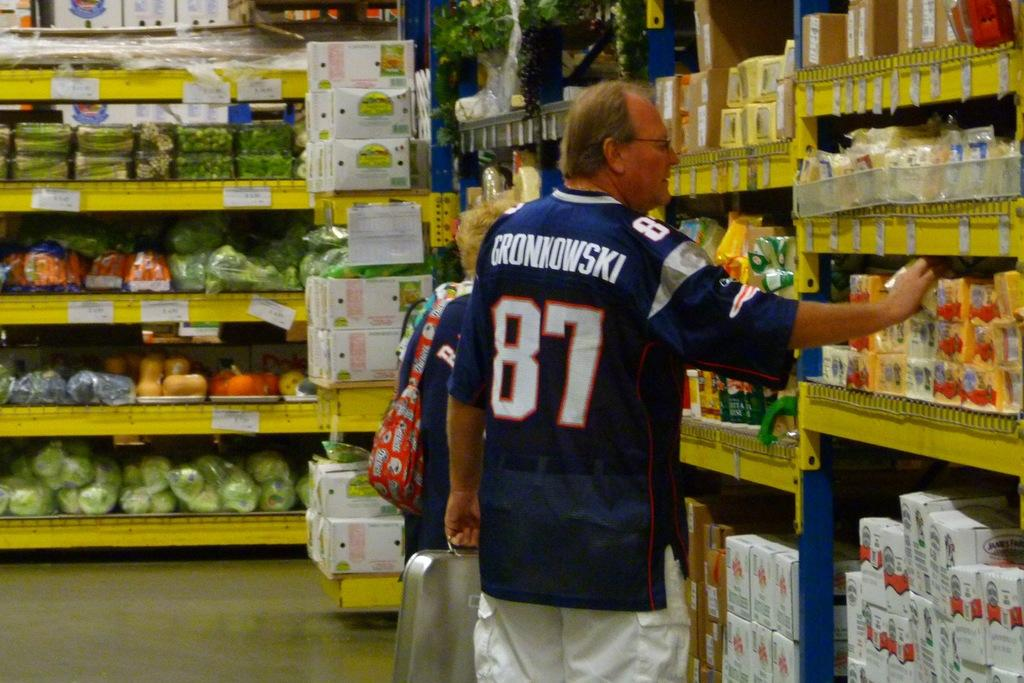<image>
Provide a brief description of the given image. a man wearing a number 87 jersey for gronkowski 